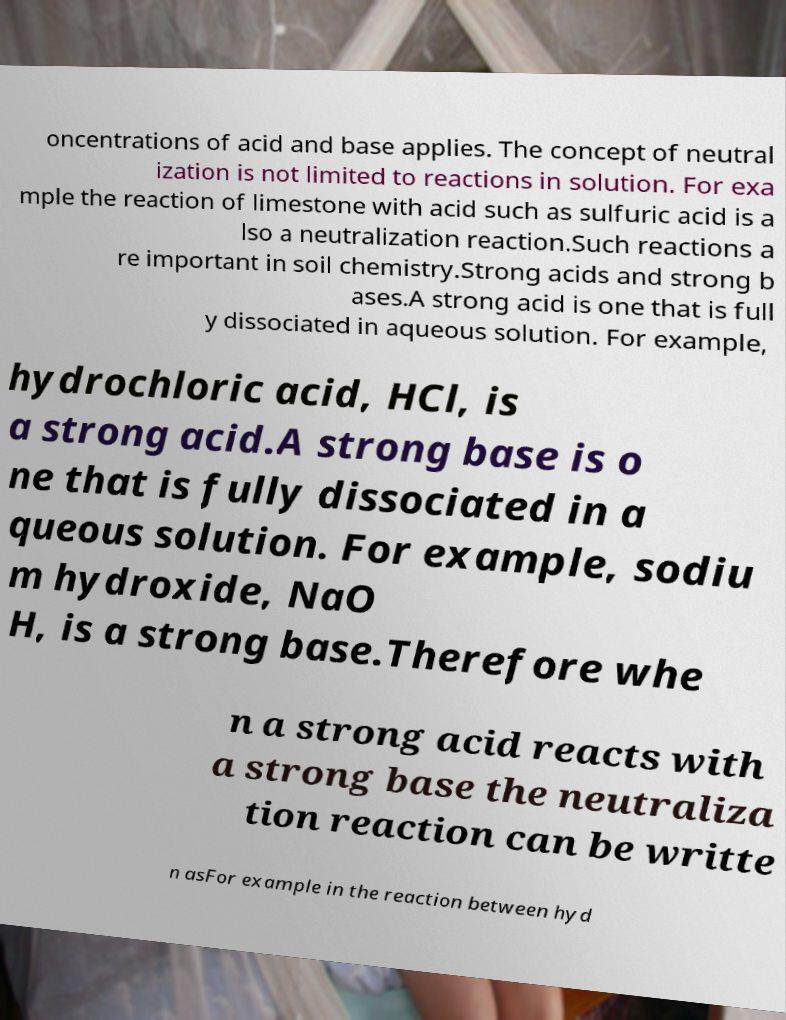Please identify and transcribe the text found in this image. oncentrations of acid and base applies. The concept of neutral ization is not limited to reactions in solution. For exa mple the reaction of limestone with acid such as sulfuric acid is a lso a neutralization reaction.Such reactions a re important in soil chemistry.Strong acids and strong b ases.A strong acid is one that is full y dissociated in aqueous solution. For example, hydrochloric acid, HCl, is a strong acid.A strong base is o ne that is fully dissociated in a queous solution. For example, sodiu m hydroxide, NaO H, is a strong base.Therefore whe n a strong acid reacts with a strong base the neutraliza tion reaction can be writte n asFor example in the reaction between hyd 